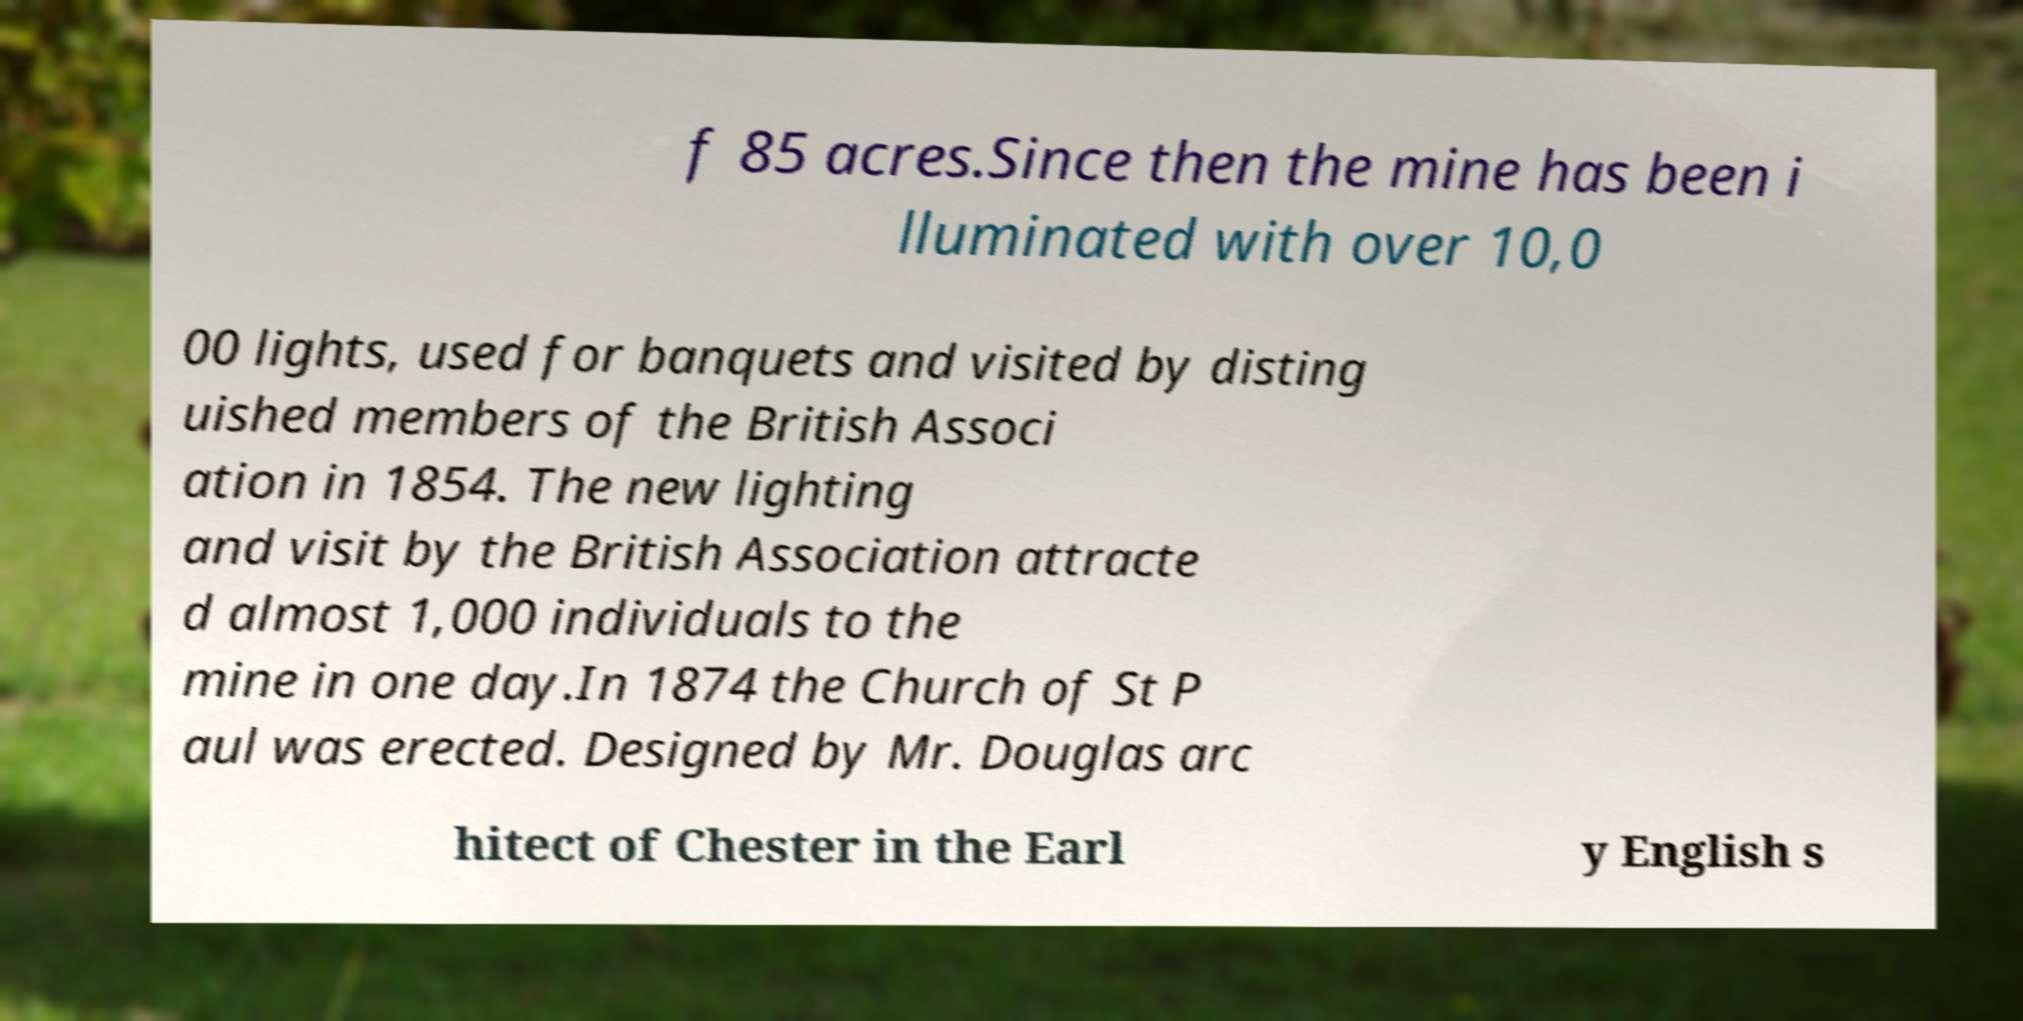Can you accurately transcribe the text from the provided image for me? f 85 acres.Since then the mine has been i lluminated with over 10,0 00 lights, used for banquets and visited by disting uished members of the British Associ ation in 1854. The new lighting and visit by the British Association attracte d almost 1,000 individuals to the mine in one day.In 1874 the Church of St P aul was erected. Designed by Mr. Douglas arc hitect of Chester in the Earl y English s 